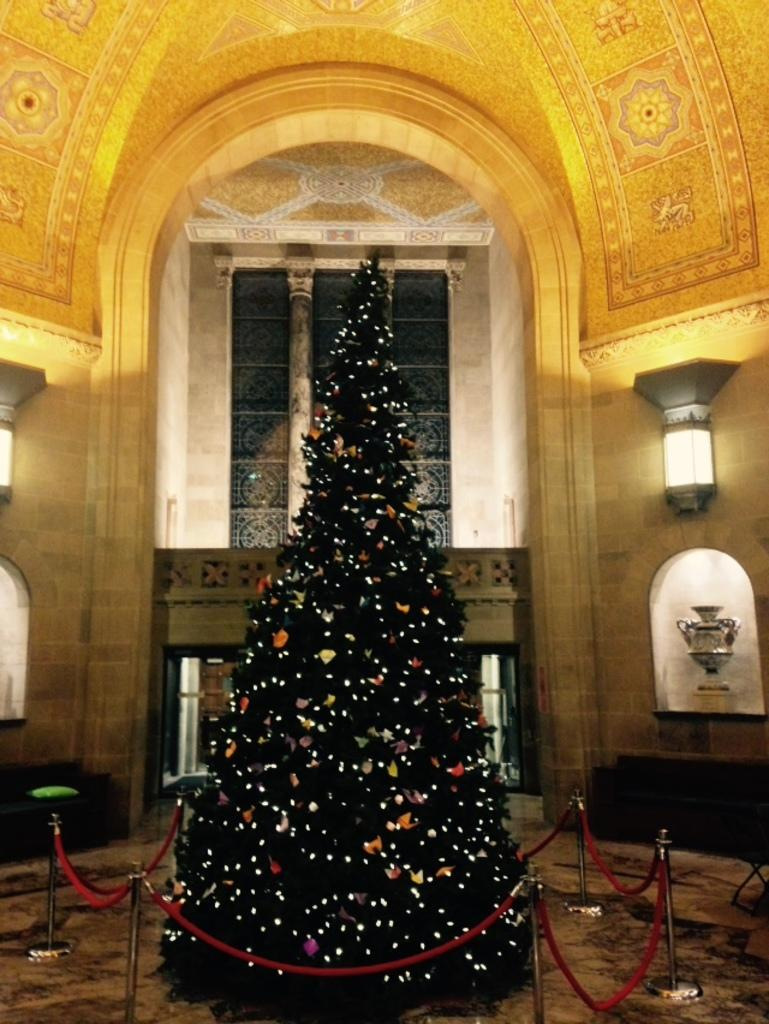What is the main feature of the tree in the image? The tree has lights in the image. What can be seen below the tree and other objects in the image? The ground is visible in the image. What structures are present in the image that support the lights or other objects? There are poles and a pillar in the image. What is the appearance of the wall in the image? The wall has lights in the image. What is attached to the pillar in the image? There are objects attached to the pillar in the image. What is the design of the roof in the image? There is a designed roof in the image. Who is the creator of the lead sculpture in the image? There is no lead sculpture present in the image. 